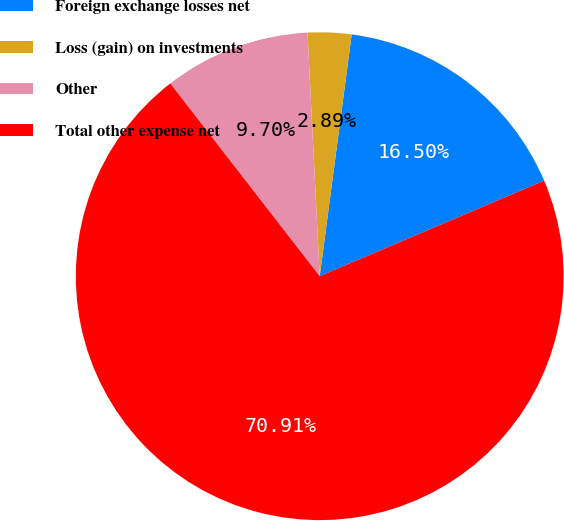Convert chart to OTSL. <chart><loc_0><loc_0><loc_500><loc_500><pie_chart><fcel>Foreign exchange losses net<fcel>Loss (gain) on investments<fcel>Other<fcel>Total other expense net<nl><fcel>16.5%<fcel>2.89%<fcel>9.7%<fcel>70.91%<nl></chart> 